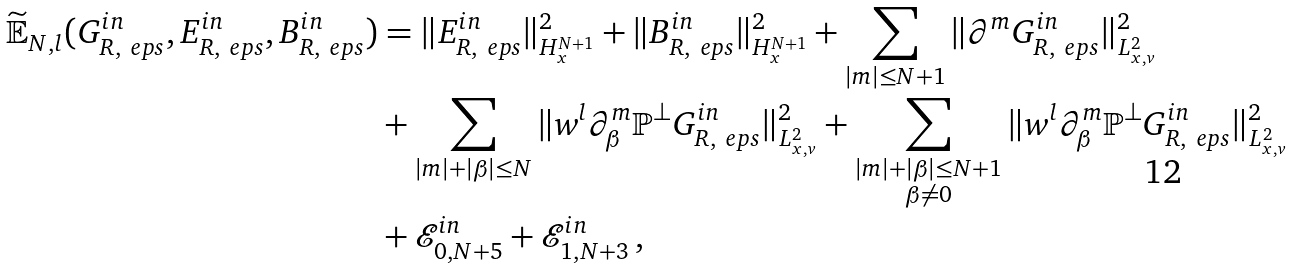<formula> <loc_0><loc_0><loc_500><loc_500>\widetilde { \mathbb { E } } _ { N , l } ( G _ { R , \ e p s } ^ { i n } , E _ { R , \ e p s } ^ { i n } , B _ { R , \ e p s } ^ { i n } ) & = \| E _ { R , \ e p s } ^ { i n } \| ^ { 2 } _ { H ^ { N + 1 } _ { x } } + \| B _ { R , \ e p s } ^ { i n } \| ^ { 2 } _ { H ^ { N + 1 } _ { x } } + \sum _ { | m | \leq N + 1 } \| \partial ^ { m } G _ { R , \ e p s } ^ { i n } \| ^ { 2 } _ { L ^ { 2 } _ { x , v } } \\ & + \sum _ { | m | + | \beta | \leq N } \| w ^ { l } \partial ^ { m } _ { \beta } \mathbb { P } ^ { \perp } G _ { R , \ e p s } ^ { i n } \| ^ { 2 } _ { L ^ { 2 } _ { x , v } } + \sum _ { \substack { | m | + | \beta | \leq N + 1 \\ \beta \neq 0 } } \| w ^ { l } \partial ^ { m } _ { \beta } \mathbb { P } ^ { \perp } G _ { R , \ e p s } ^ { i n } \| ^ { 2 } _ { L ^ { 2 } _ { x , v } } \\ & + \mathcal { E } _ { 0 , N + 5 } ^ { i n } + \mathcal { E } _ { 1 , N + 3 } ^ { i n } \, ,</formula> 